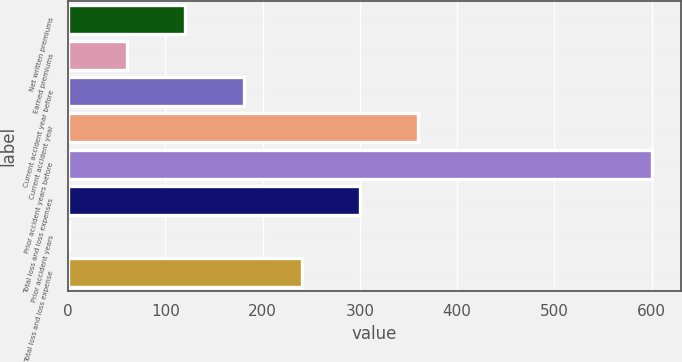Convert chart to OTSL. <chart><loc_0><loc_0><loc_500><loc_500><bar_chart><fcel>Net written premiums<fcel>Earned premiums<fcel>Current accident year before<fcel>Current accident year<fcel>Prior accident years before<fcel>Total loss and loss expenses<fcel>Prior accident years<fcel>Total loss and loss expense<nl><fcel>120.48<fcel>60.54<fcel>180.42<fcel>360.24<fcel>600<fcel>300.3<fcel>0.6<fcel>240.36<nl></chart> 